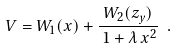Convert formula to latex. <formula><loc_0><loc_0><loc_500><loc_500>V = W _ { 1 } ( x ) + \frac { W _ { 2 } ( z _ { y } ) } { \, 1 + \lambda \, x ^ { 2 } } \ .</formula> 